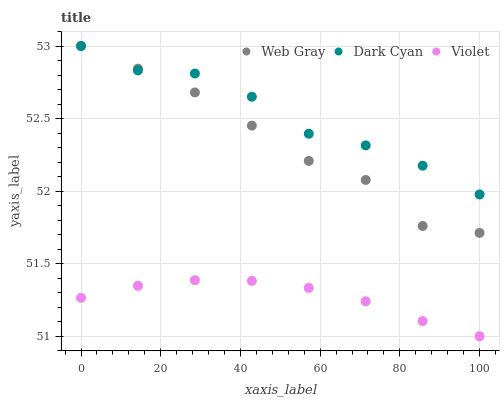Does Violet have the minimum area under the curve?
Answer yes or no. Yes. Does Dark Cyan have the maximum area under the curve?
Answer yes or no. Yes. Does Web Gray have the minimum area under the curve?
Answer yes or no. No. Does Web Gray have the maximum area under the curve?
Answer yes or no. No. Is Violet the smoothest?
Answer yes or no. Yes. Is Dark Cyan the roughest?
Answer yes or no. Yes. Is Web Gray the smoothest?
Answer yes or no. No. Is Web Gray the roughest?
Answer yes or no. No. Does Violet have the lowest value?
Answer yes or no. Yes. Does Web Gray have the lowest value?
Answer yes or no. No. Does Web Gray have the highest value?
Answer yes or no. Yes. Does Violet have the highest value?
Answer yes or no. No. Is Violet less than Dark Cyan?
Answer yes or no. Yes. Is Dark Cyan greater than Violet?
Answer yes or no. Yes. Does Dark Cyan intersect Web Gray?
Answer yes or no. Yes. Is Dark Cyan less than Web Gray?
Answer yes or no. No. Is Dark Cyan greater than Web Gray?
Answer yes or no. No. Does Violet intersect Dark Cyan?
Answer yes or no. No. 